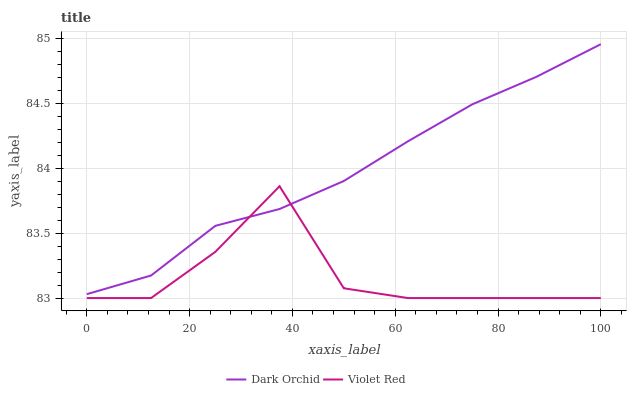Does Violet Red have the minimum area under the curve?
Answer yes or no. Yes. Does Dark Orchid have the maximum area under the curve?
Answer yes or no. Yes. Does Dark Orchid have the minimum area under the curve?
Answer yes or no. No. Is Dark Orchid the smoothest?
Answer yes or no. Yes. Is Violet Red the roughest?
Answer yes or no. Yes. Is Dark Orchid the roughest?
Answer yes or no. No. Does Dark Orchid have the lowest value?
Answer yes or no. No. Does Dark Orchid have the highest value?
Answer yes or no. Yes. 